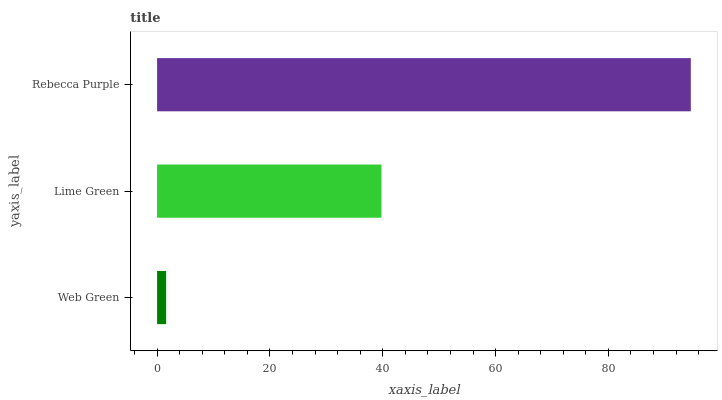Is Web Green the minimum?
Answer yes or no. Yes. Is Rebecca Purple the maximum?
Answer yes or no. Yes. Is Lime Green the minimum?
Answer yes or no. No. Is Lime Green the maximum?
Answer yes or no. No. Is Lime Green greater than Web Green?
Answer yes or no. Yes. Is Web Green less than Lime Green?
Answer yes or no. Yes. Is Web Green greater than Lime Green?
Answer yes or no. No. Is Lime Green less than Web Green?
Answer yes or no. No. Is Lime Green the high median?
Answer yes or no. Yes. Is Lime Green the low median?
Answer yes or no. Yes. Is Web Green the high median?
Answer yes or no. No. Is Web Green the low median?
Answer yes or no. No. 